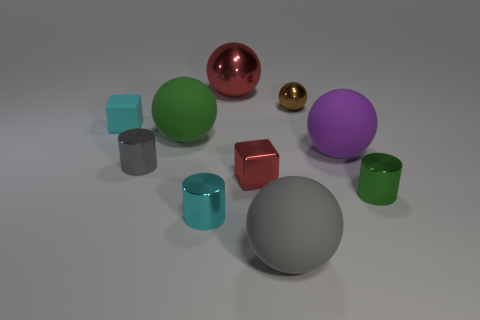What size is the gray object that is on the left side of the cylinder that is in front of the green thing right of the tiny brown metal sphere?
Ensure brevity in your answer.  Small. There is a cylinder that is to the right of the cyan shiny thing; what is its size?
Make the answer very short. Small. What number of gray things are matte things or large metal things?
Ensure brevity in your answer.  1. Are there any gray rubber objects of the same size as the purple object?
Provide a short and direct response. Yes. There is a gray cylinder that is the same size as the cyan metallic cylinder; what material is it?
Give a very brief answer. Metal. Does the cyan thing that is behind the purple matte object have the same size as the red shiny object in front of the gray metallic cylinder?
Ensure brevity in your answer.  Yes. How many objects are either tiny shiny things or metal cylinders on the left side of the large gray object?
Offer a very short reply. 5. Is there a brown metallic thing that has the same shape as the tiny cyan metallic thing?
Your answer should be compact. No. What is the size of the matte sphere on the left side of the matte object that is in front of the purple rubber ball?
Offer a terse response. Large. Do the tiny metal cube and the tiny matte cube have the same color?
Your answer should be very brief. No. 